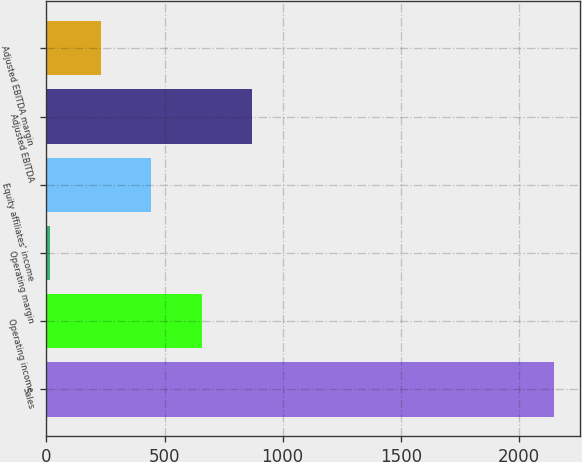<chart> <loc_0><loc_0><loc_500><loc_500><bar_chart><fcel>Sales<fcel>Operating income<fcel>Operating margin<fcel>Equity affiliates' income<fcel>Adjusted EBITDA<fcel>Adjusted EBITDA margin<nl><fcel>2150.7<fcel>656.62<fcel>16.3<fcel>443.18<fcel>870.06<fcel>229.74<nl></chart> 